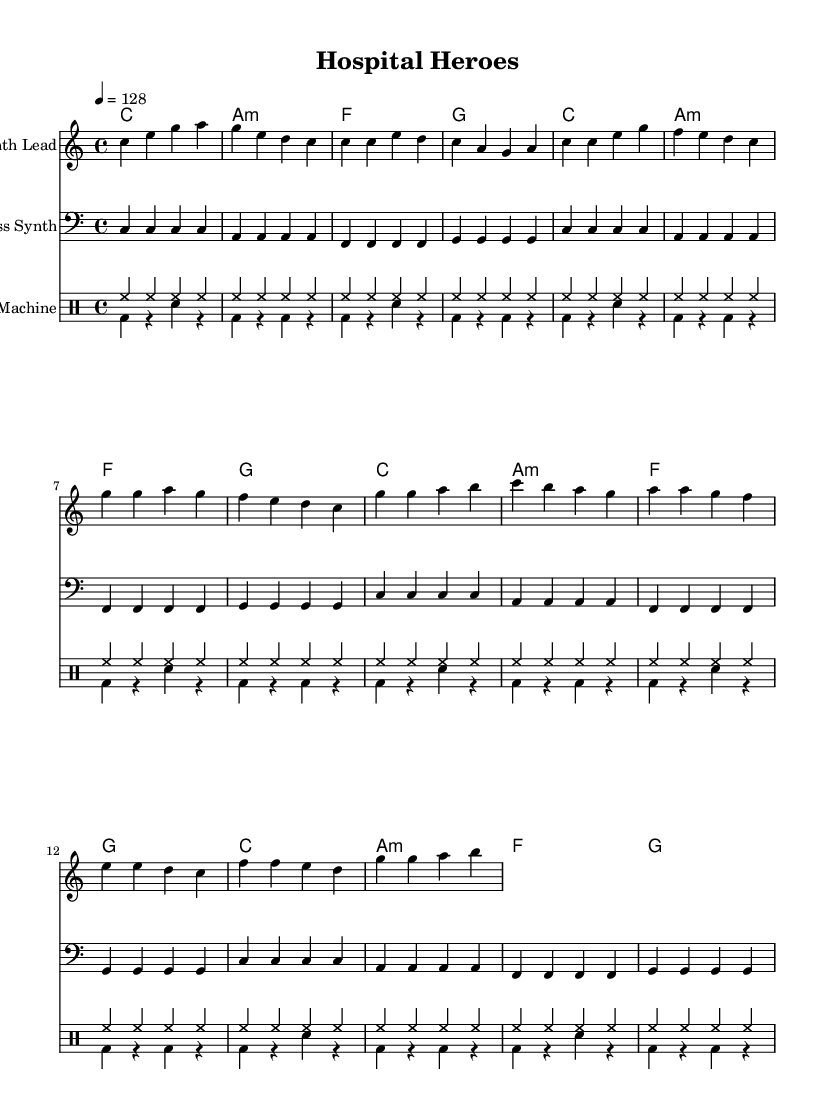What is the key signature of this music? The key signature is C major, which has no sharps or flats.
Answer: C major What is the time signature of this music? The time signature is indicated as 4/4, meaning there are four beats per measure.
Answer: 4/4 What is the tempo marking for this piece? The tempo marking is set at 128 beats per minute, indicated by the tempo marking.
Answer: 128 How many measures are in the chorus section? The chorus section consists of 4 measures, as seen in the structured music notation.
Answer: 4 What chord is played in the first measure? The first measure shows a C major chord being used, as indicated in the harmonies section.
Answer: C How many repetitions of the hi-hat pattern are there in the drum section? The hi-hat pattern repeats 16 times, as specified in the drum-up notation.
Answer: 16 Which instrument is indicated to play the melody? The melody is indicated to be played by the "Synth Lead" instrument, as noted on the staff.
Answer: Synth Lead 